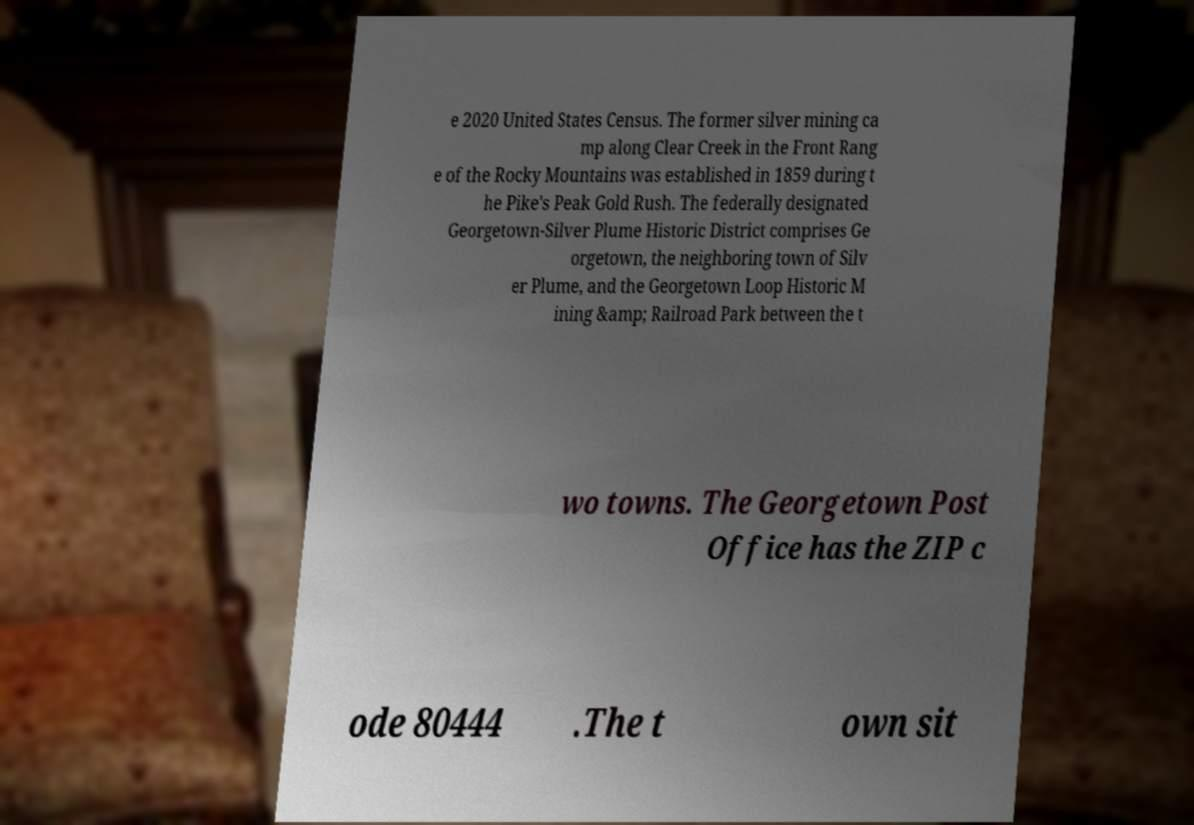Could you assist in decoding the text presented in this image and type it out clearly? e 2020 United States Census. The former silver mining ca mp along Clear Creek in the Front Rang e of the Rocky Mountains was established in 1859 during t he Pike's Peak Gold Rush. The federally designated Georgetown-Silver Plume Historic District comprises Ge orgetown, the neighboring town of Silv er Plume, and the Georgetown Loop Historic M ining &amp; Railroad Park between the t wo towns. The Georgetown Post Office has the ZIP c ode 80444 .The t own sit 